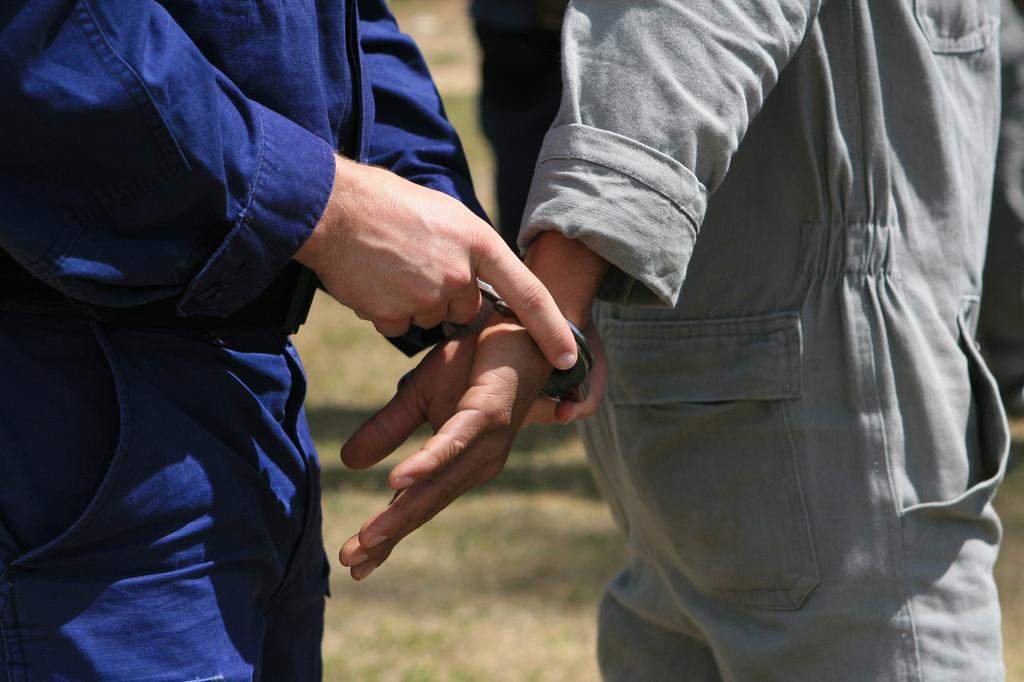What body parts are visible in the image? There are two persons' hands in the image. What objects are connected to the hands in the image? Handcuffs are visible in the image. What type of silk fabric is draped over the hands in the image? There is no silk fabric present in the image; only hands and handcuffs are visible. 